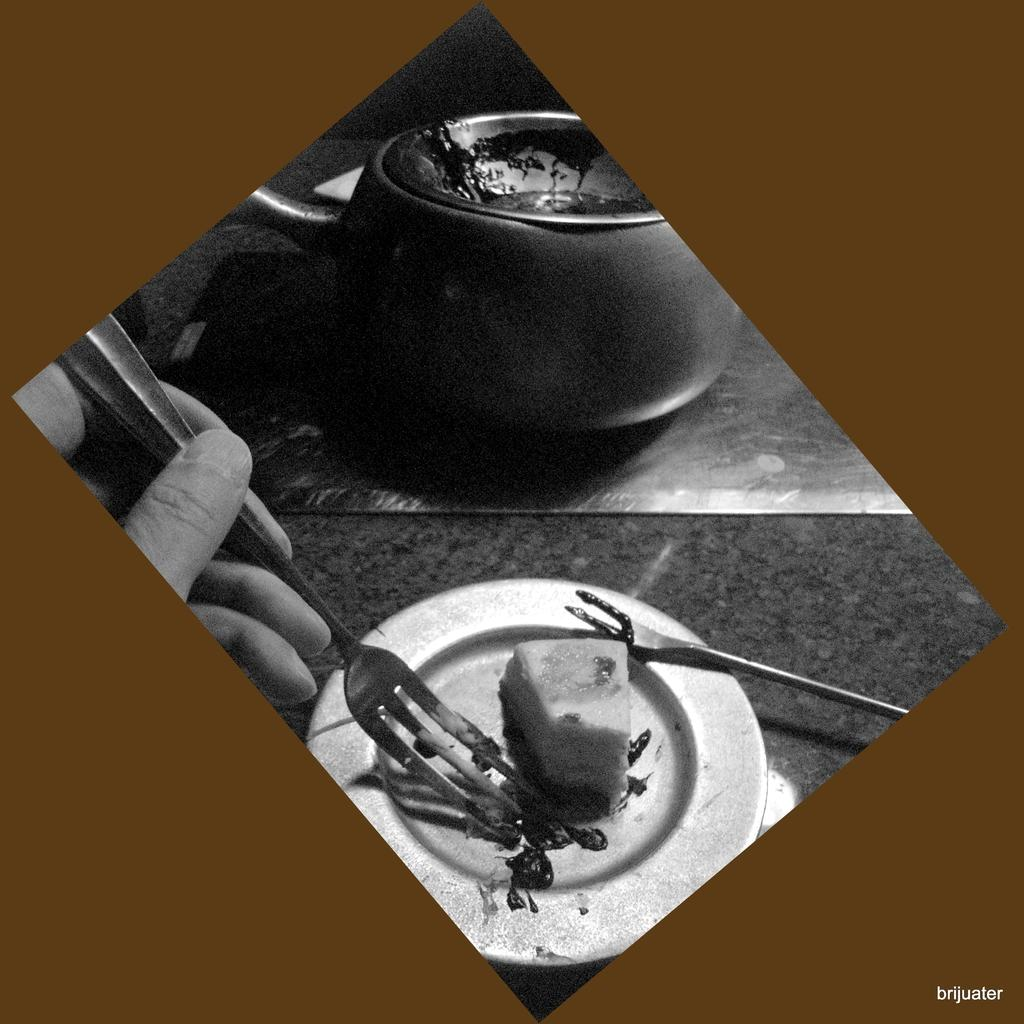What is on the plate that is visible in the image? There is food placed in a plate in the image. Who is holding a utensil in the image? There is a person holding a fork in the image. What can be seen in the background of the image? There is a kettle in the background of the image. What type of lift is present in the image? There is no lift present in the image. Is this a birthday party scene in the image? The provided facts do not mention any birthday party elements, so it cannot be confirmed from the image. 